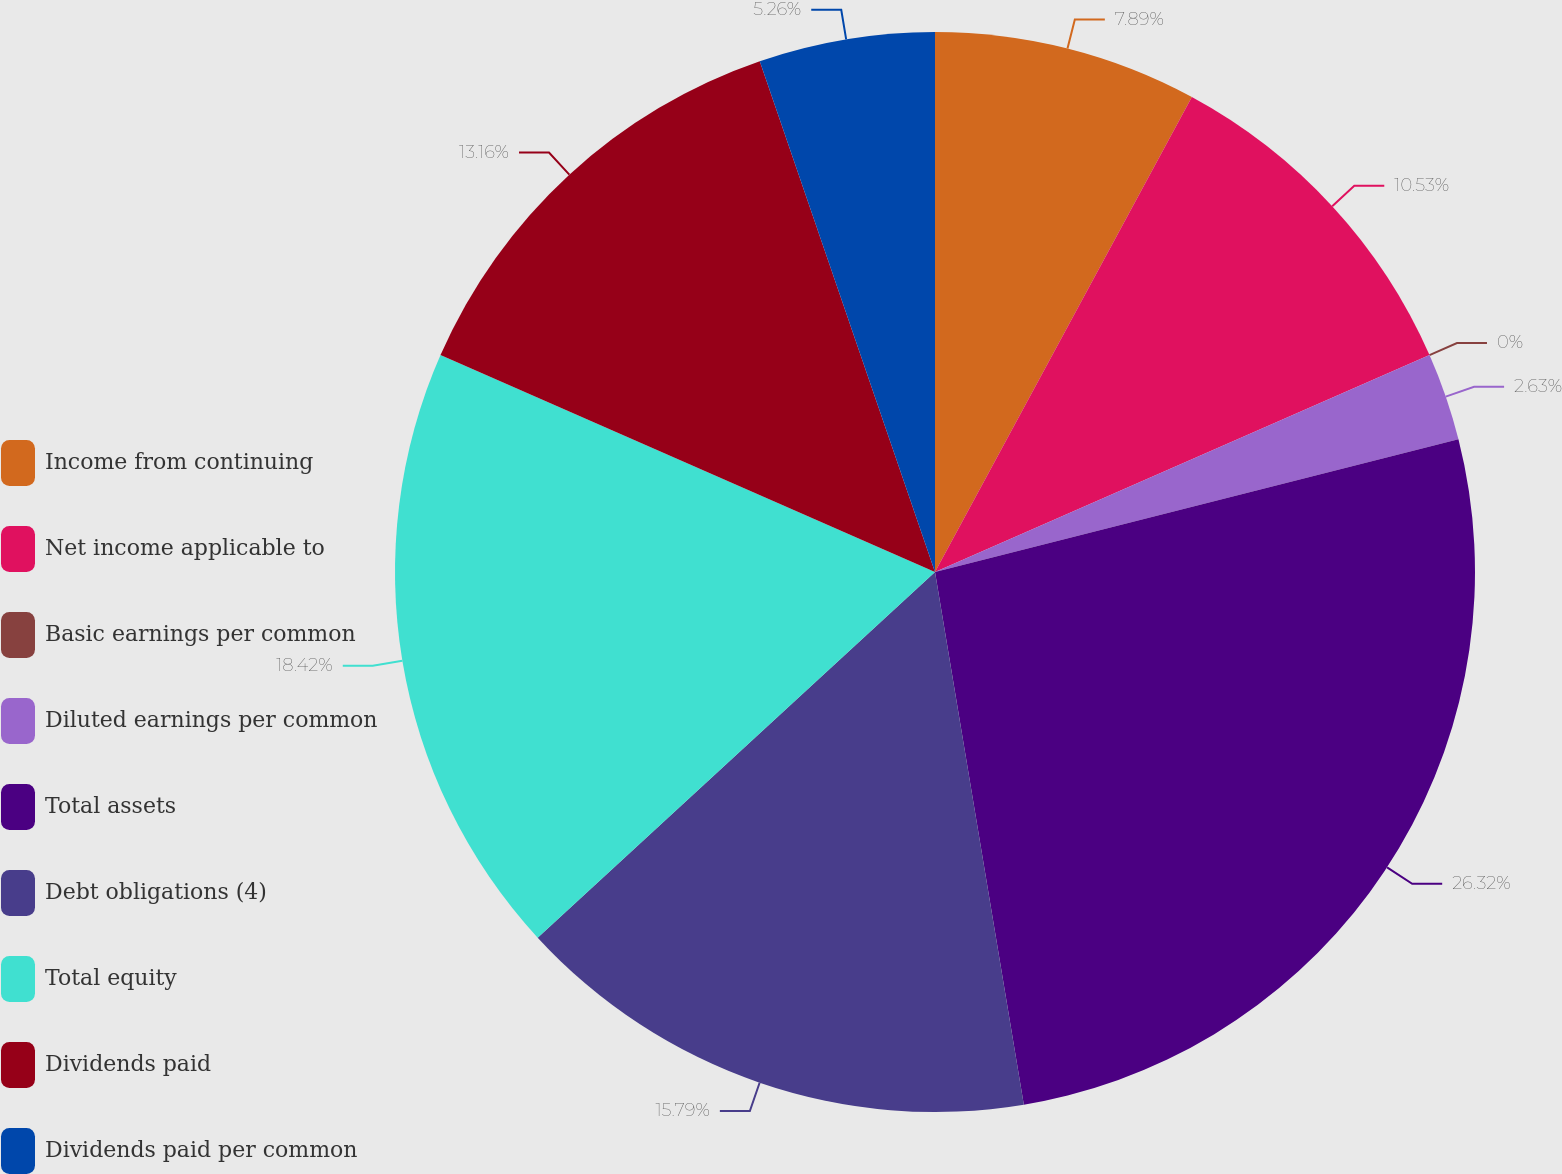Convert chart. <chart><loc_0><loc_0><loc_500><loc_500><pie_chart><fcel>Income from continuing<fcel>Net income applicable to<fcel>Basic earnings per common<fcel>Diluted earnings per common<fcel>Total assets<fcel>Debt obligations (4)<fcel>Total equity<fcel>Dividends paid<fcel>Dividends paid per common<nl><fcel>7.89%<fcel>10.53%<fcel>0.0%<fcel>2.63%<fcel>26.32%<fcel>15.79%<fcel>18.42%<fcel>13.16%<fcel>5.26%<nl></chart> 